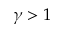Convert formula to latex. <formula><loc_0><loc_0><loc_500><loc_500>\gamma > 1</formula> 